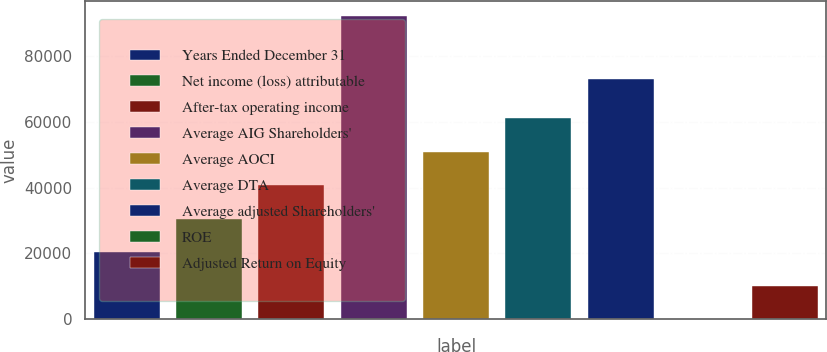Convert chart. <chart><loc_0><loc_0><loc_500><loc_500><bar_chart><fcel>Years Ended December 31<fcel>Net income (loss) attributable<fcel>After-tax operating income<fcel>Average AIG Shareholders'<fcel>Average AOCI<fcel>Average DTA<fcel>Average adjusted Shareholders'<fcel>ROE<fcel>Adjusted Return on Equity<nl><fcel>20377.3<fcel>30564.3<fcel>40751.2<fcel>92155<fcel>50938.2<fcel>61125.2<fcel>72905<fcel>3.4<fcel>10190.4<nl></chart> 